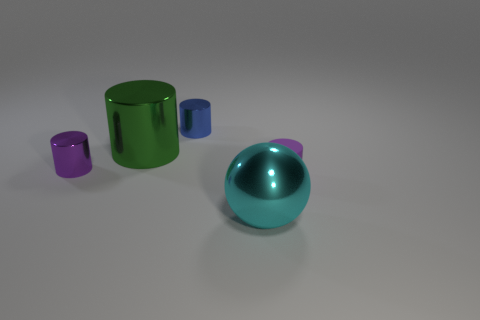Does the purple object that is to the left of the big cyan sphere have the same material as the purple object on the right side of the metallic ball?
Offer a terse response. No. What is the size of the purple cylinder that is behind the matte object?
Ensure brevity in your answer.  Small. What size is the rubber object?
Your response must be concise. Small. There is a purple thing behind the purple cylinder that is right of the metallic object that is to the right of the blue shiny object; how big is it?
Your response must be concise. Small. Are there any purple things that have the same material as the ball?
Make the answer very short. Yes. What is the shape of the tiny purple rubber thing?
Keep it short and to the point. Cylinder. What color is the other large object that is made of the same material as the big green object?
Offer a very short reply. Cyan. What number of purple things are either matte cylinders or big matte objects?
Your answer should be compact. 1. Are there more large green things than tiny green metal spheres?
Your answer should be very brief. Yes. How many things are either large metallic things behind the shiny sphere or large objects left of the blue metallic thing?
Provide a succinct answer. 1. 